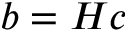Convert formula to latex. <formula><loc_0><loc_0><loc_500><loc_500>b = H c</formula> 